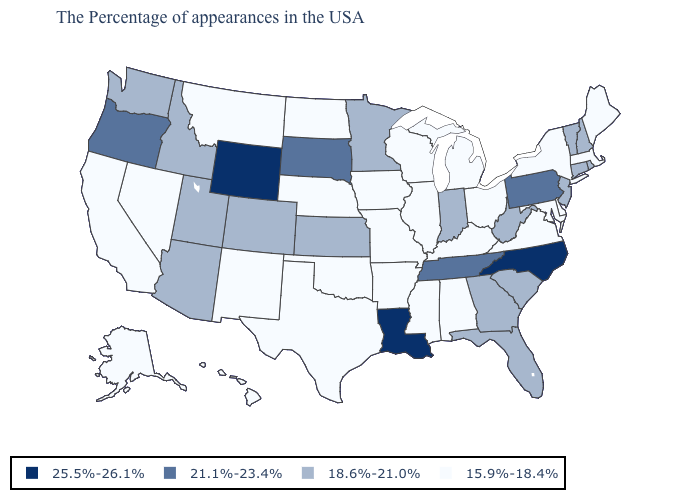What is the value of Georgia?
Give a very brief answer. 18.6%-21.0%. Is the legend a continuous bar?
Quick response, please. No. What is the value of Nebraska?
Concise answer only. 15.9%-18.4%. Name the states that have a value in the range 25.5%-26.1%?
Short answer required. North Carolina, Louisiana, Wyoming. What is the value of Virginia?
Concise answer only. 15.9%-18.4%. What is the value of Arizona?
Keep it brief. 18.6%-21.0%. Does Texas have the lowest value in the South?
Short answer required. Yes. Does Connecticut have the highest value in the USA?
Be succinct. No. Which states have the highest value in the USA?
Quick response, please. North Carolina, Louisiana, Wyoming. Among the states that border Maryland , does Pennsylvania have the highest value?
Short answer required. Yes. Does Arizona have a higher value than Oklahoma?
Short answer required. Yes. What is the lowest value in the USA?
Short answer required. 15.9%-18.4%. What is the highest value in the USA?
Short answer required. 25.5%-26.1%. Among the states that border Nevada , which have the lowest value?
Be succinct. California. Does Alabama have the lowest value in the USA?
Short answer required. Yes. 